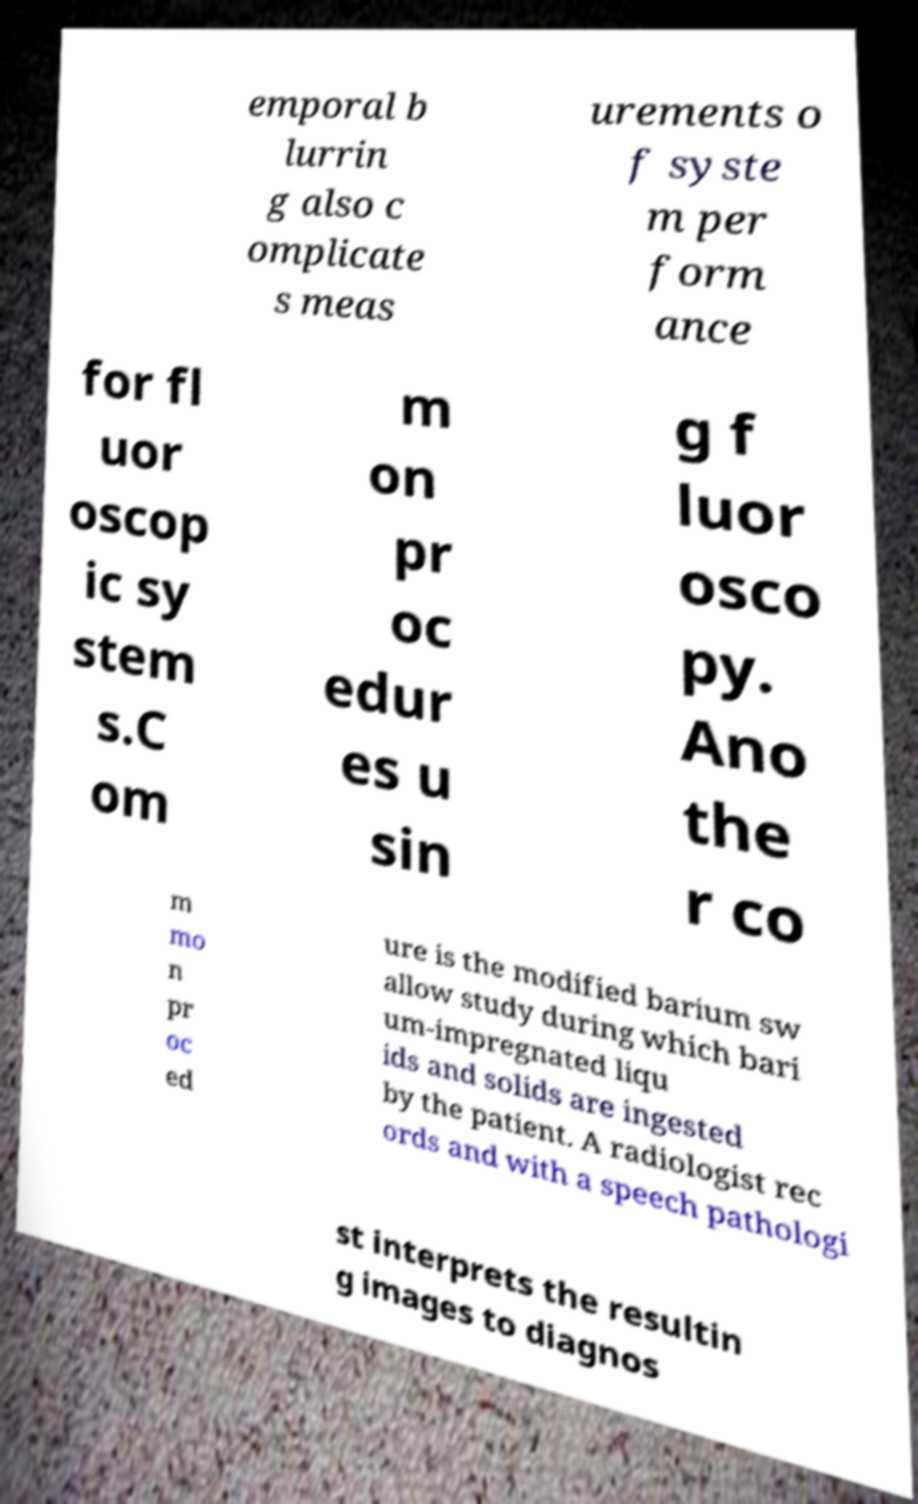What messages or text are displayed in this image? I need them in a readable, typed format. emporal b lurrin g also c omplicate s meas urements o f syste m per form ance for fl uor oscop ic sy stem s.C om m on pr oc edur es u sin g f luor osco py. Ano the r co m mo n pr oc ed ure is the modified barium sw allow study during which bari um-impregnated liqu ids and solids are ingested by the patient. A radiologist rec ords and with a speech pathologi st interprets the resultin g images to diagnos 